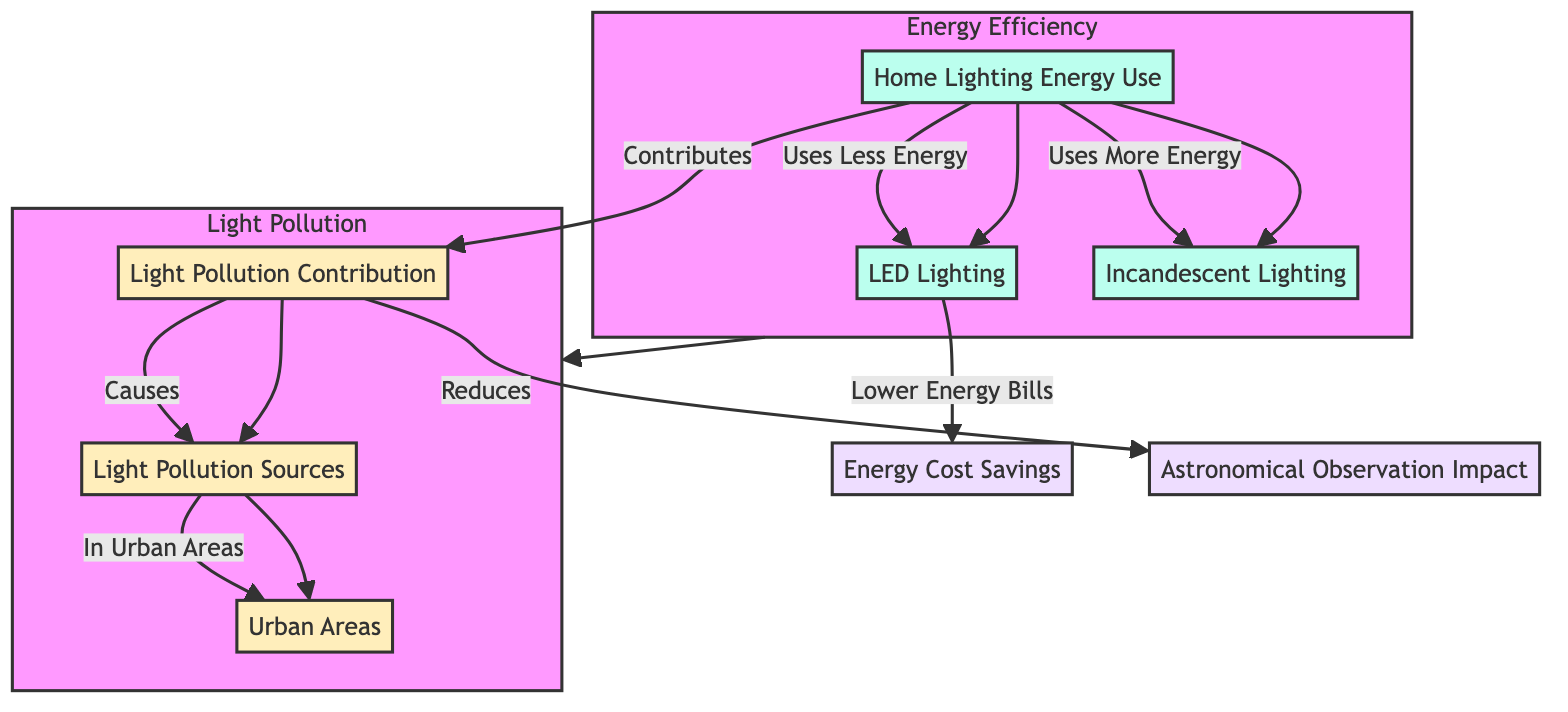What is the main source of energy use in home lighting? The diagram indicates that the main source of energy use in home lighting is represented by Home Lighting Energy Use.
Answer: Home Lighting Energy Use Which type of lighting uses less energy? The diagram shows that LED Lighting uses less energy compared to Incandescent Lighting, as indicated by the flow from Home Lighting Energy Use to LED Lighting.
Answer: LED Lighting How does energy-efficient lighting affect energy bills? According to the diagram, LED Lighting provides Lower Energy Bills as a result of its energy efficiency, connecting Home Lighting Energy Use to Energy Cost Savings.
Answer: Lower Energy Bills What type of pollution is specifically highlighted in this diagram? The diagram illustrates that Light Pollution Contribution is the type of pollution being discussed, as shown in the pollution section.
Answer: Light Pollution Contribution What is the relationship between light pollution and urban areas? The flow in the diagram indicates that Light Pollution Sources contribute significantly to the presence of light pollution specifically in Urban Areas.
Answer: Urban Areas Which type of lighting contributes more to light pollution? The diagram shows that Incandescent Lighting contributes more to Light Pollution compared to LED Lighting, as indicated by the different energy use levels.
Answer: Incandescent Lighting What is the impact of light pollution on astronomical observation? The diagram states that Light Pollution reduces the Astronomical Observation Impact, highlighting the negative effects of light pollution on astronomy.
Answer: Reduces How many nodes are there in the Pollution subgraph? The Pollution subgraph contains three nodes: Light Pollution Contribution, Light Pollution Sources, and Urban Areas, as consistently represented in the diagram.
Answer: Three What is one factor that leads to energy cost savings? The diagram indicates that Lower Energy Bills, resulting from the use of LED Lighting, is a crucial factor leading to energy cost savings.
Answer: Lower Energy Bills What does the diagram suggest is a reason for light pollution? The diagram suggests that Light Pollution Sources are the major reason for light pollution, connecting the pollution concepts observed in urban settings.
Answer: Light Pollution Sources 